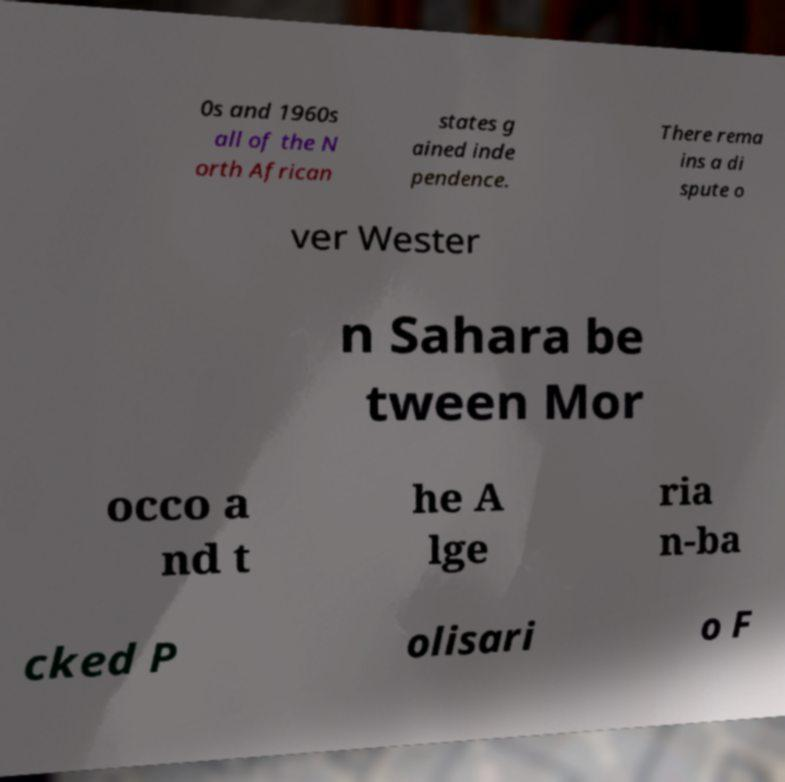What messages or text are displayed in this image? I need them in a readable, typed format. 0s and 1960s all of the N orth African states g ained inde pendence. There rema ins a di spute o ver Wester n Sahara be tween Mor occo a nd t he A lge ria n-ba cked P olisari o F 